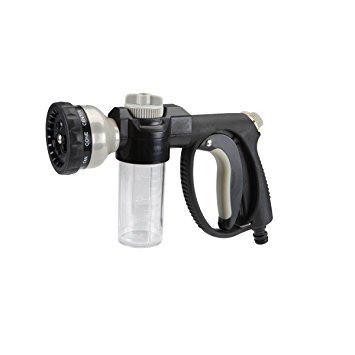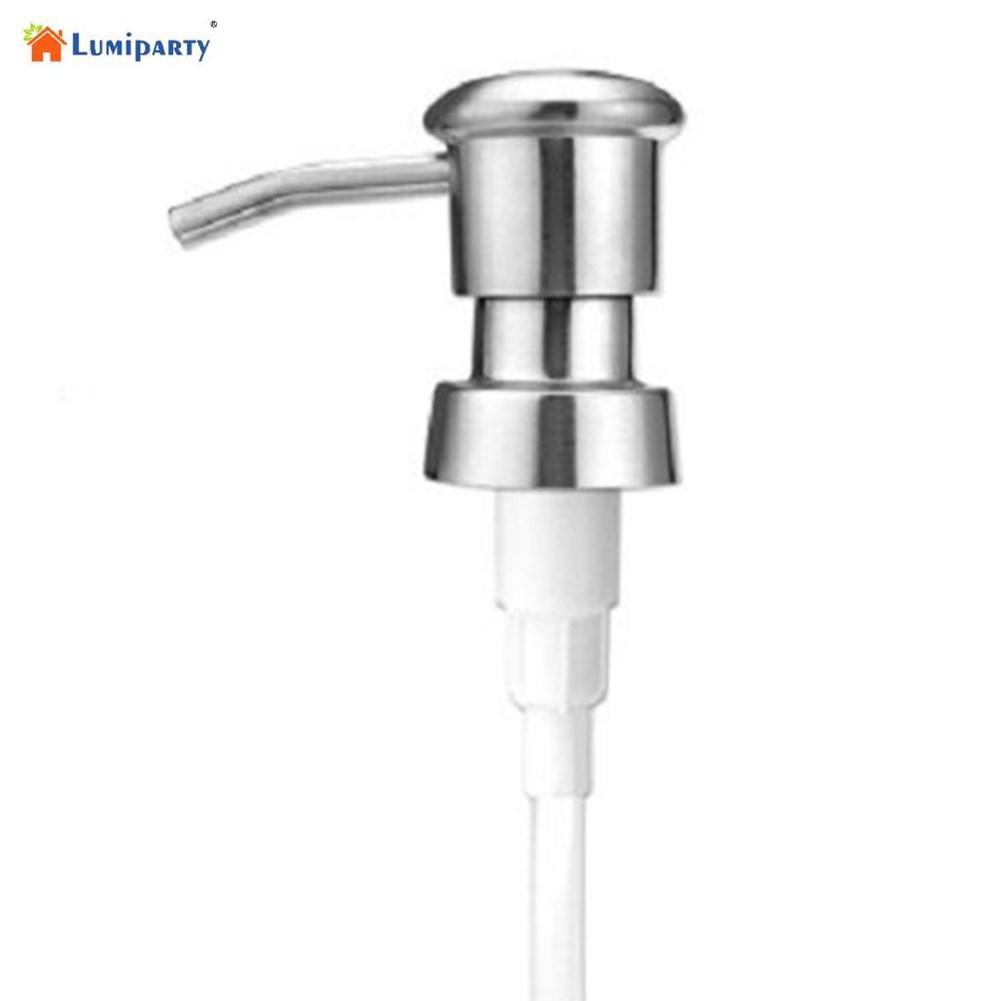The first image is the image on the left, the second image is the image on the right. Examine the images to the left and right. Is the description "The left and right image contains the same number of soap pumps." accurate? Answer yes or no. No. The first image is the image on the left, the second image is the image on the right. Examine the images to the left and right. Is the description "The nozzle in the left image is silver colored." accurate? Answer yes or no. No. 